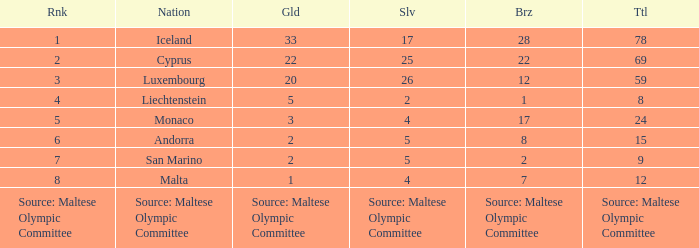How many gold medals can be found when 8 bronze medals are present? 2.0. 